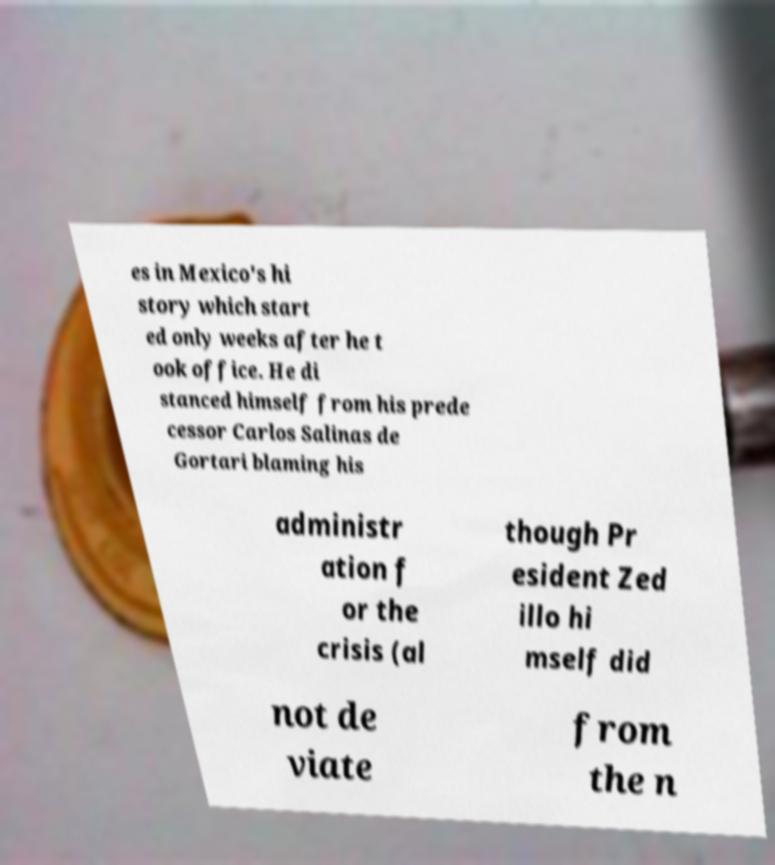Please read and relay the text visible in this image. What does it say? es in Mexico's hi story which start ed only weeks after he t ook office. He di stanced himself from his prede cessor Carlos Salinas de Gortari blaming his administr ation f or the crisis (al though Pr esident Zed illo hi mself did not de viate from the n 